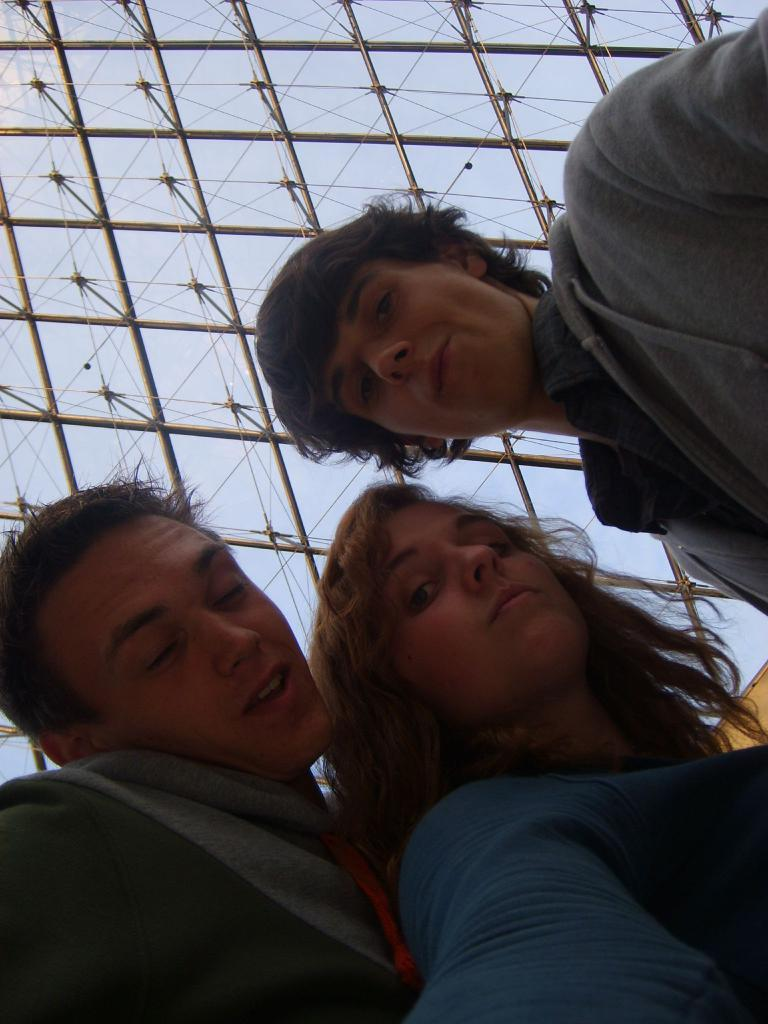How many people are in the image? There are three people standing together in the image. What is visible above the people? The roof with poles is visible above the people. Can you see any part of the sky in the image? Yes, a part of the sky is visible through the roof. What type of leaf is being used as a paper by one of the people in the image? There is no leaf or paper present in the image, and no one is using any object as a paper. 